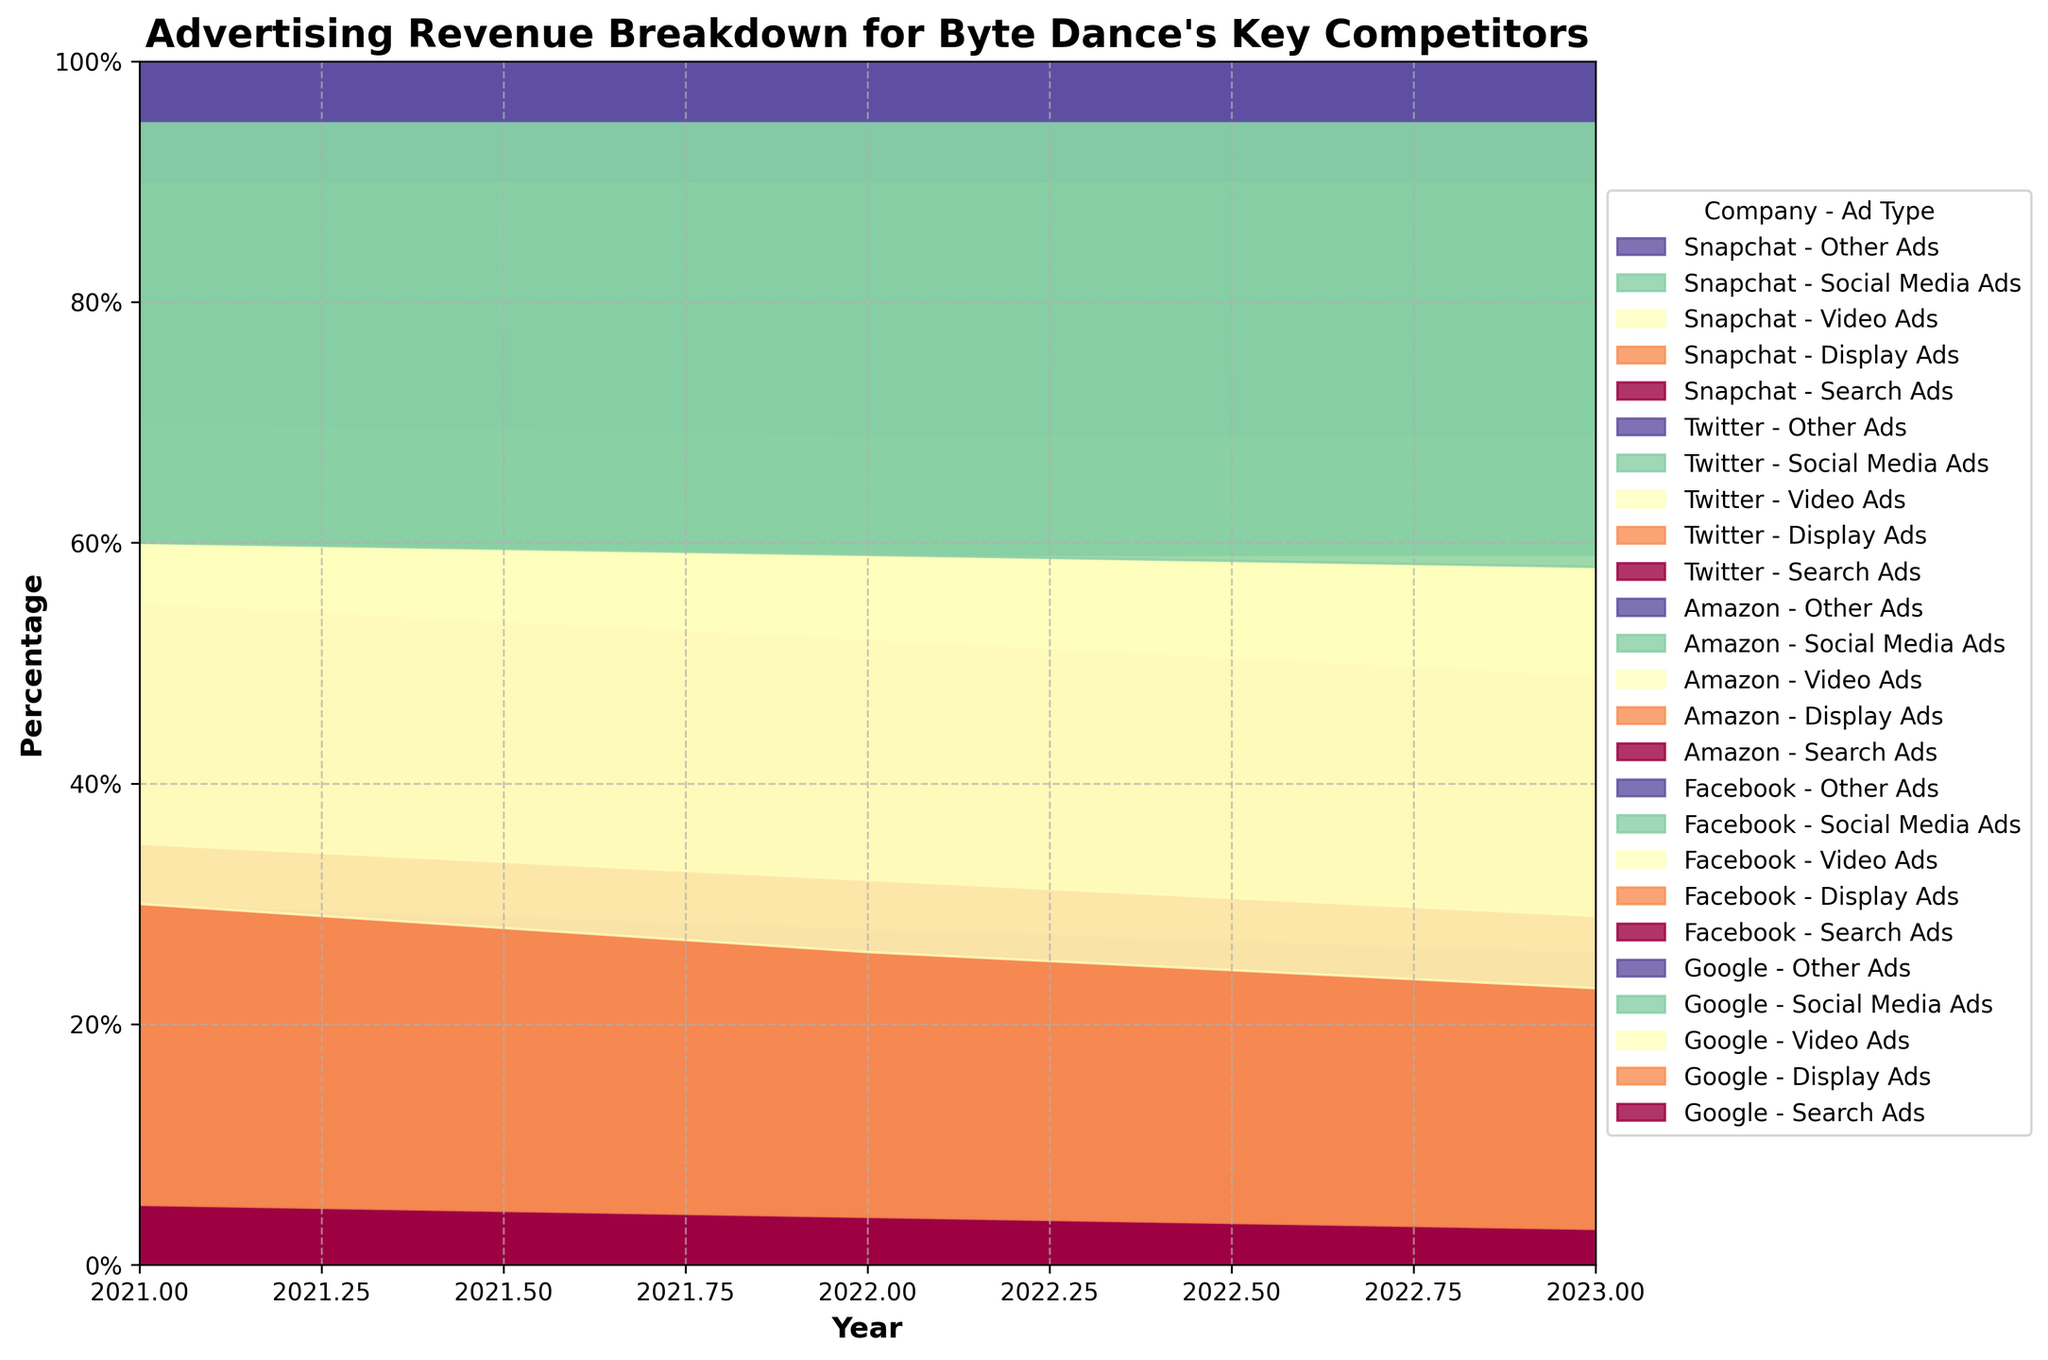How many types of advertisement are divided in the figure? The figure divides advertising revenue into five categories. This can be seen from the legend that lists Search Ads, Display Ads, Video Ads, Social Media Ads, and Other Ads.
Answer: Five What company focuses the most on Social Media Ads in 2023 according to the plot? By examining the plot, the company with the largest area corresponding to Social Media Ads (in a reddish-brown color) in 2023 is Twitter.
Answer: Twitter How did the percentage of Google's Search Ads revenue change from 2021 to 2023? To find this, compare the areas representing Search Ads for Google in the years 2021 and 2023. In 2021, it is at 60%, and by 2023, it has decreased to 55%. So, there is a 5% decrease.
Answer: Decreased by 5% Comparing 2022, which company had the highest percent revenue from Video Ads? Examine the plot for 2022 and identify the area proportions for Video Ads (in a greenish color). Facebook has the highest percentage for Video Ads in 2022.
Answer: Facebook Between Amazon and Snapchat, which company had a greater percent decrease in Display Ads from 2021 to 2023? Check the areas representing Display Ads for both companies in 2021 and 2023. Amazon's Display Ads went from 25% to 23% (2% decrease), while Snapchat's Display Ads went from 25% to 20% (5% decrease). Therefore, Snapchat had a greater decrease.
Answer: Snapchat What is the observed trend in Video Ads for Facebook from 2021 through 2023? To find the trend, look at the filled area for Video Ads (greenish) for Facebook. It starts at 20% in 2021, increases to 23% in 2022, and further increases to 25% in 2023, showing a rising trend.
Answer: Increasing trend What can be said about the Other Ads category compared across all companies in 2023? In the plot, observe the contribution of Other Ads in 2023 across all companies. Other Ads remain at a small and constant percentage of 5% across all companies.
Answer: Constant at 5% Which two companies had roughly equal revenue distribution among all ad types in 2023? By looking at the stacked areas, Amazon and Twitter have a more evenly distributed revenue breakdown among all ad types compared to other companies, particularly in 2023.
Answer: Amazon and Twitter 